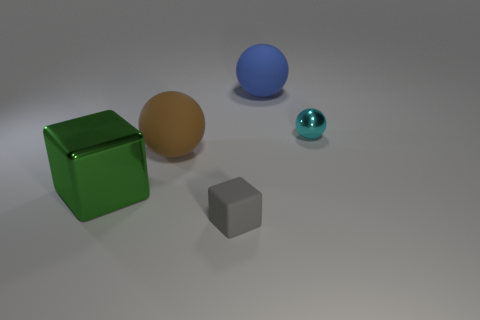What is the shape of the cyan metal object?
Your answer should be very brief. Sphere. The cyan thing that is the same shape as the blue thing is what size?
Your answer should be compact. Small. What size is the metal object behind the big rubber thing that is left of the tiny gray rubber object?
Your response must be concise. Small. Are there the same number of green metal cubes behind the big blue rubber ball and tiny yellow matte cylinders?
Keep it short and to the point. Yes. Is the number of metal things that are on the left side of the gray object less than the number of yellow cylinders?
Provide a short and direct response. No. Are there any purple matte cylinders that have the same size as the cyan object?
Offer a terse response. No. How many tiny gray matte things are left of the cube that is behind the small rubber block?
Make the answer very short. 0. The large rubber thing behind the big matte object that is in front of the small cyan metal thing is what color?
Your answer should be compact. Blue. There is a ball that is in front of the blue matte sphere and on the left side of the cyan object; what material is it?
Your answer should be compact. Rubber. Are there any small shiny things that have the same shape as the big brown thing?
Offer a very short reply. Yes. 